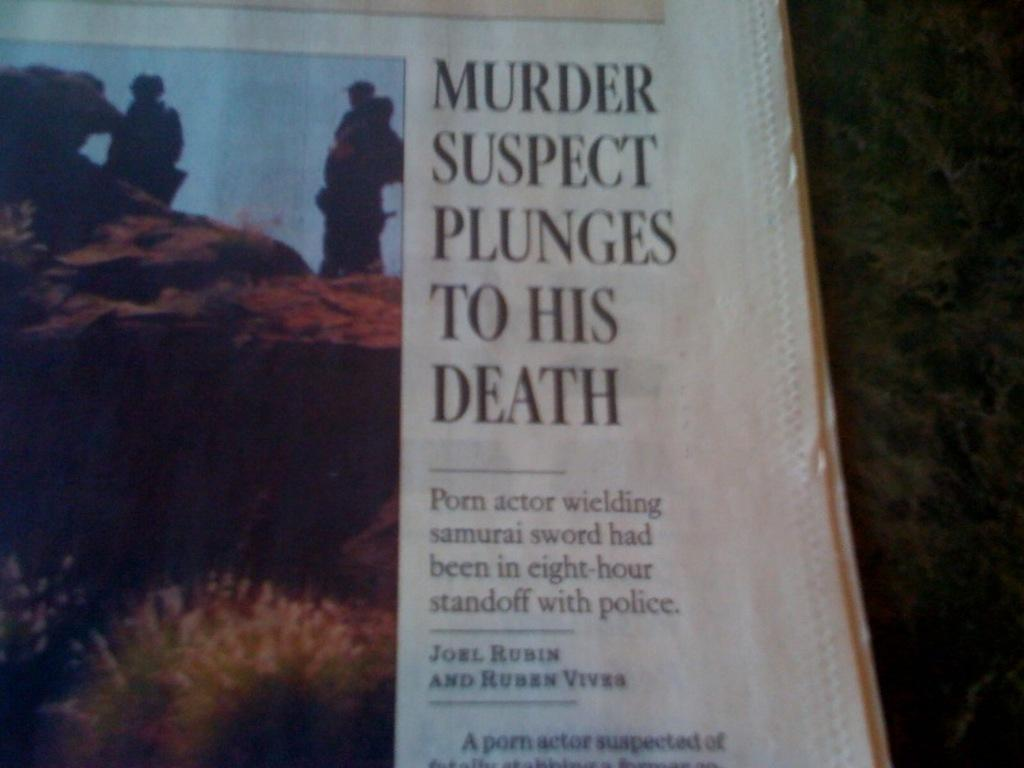Provide a one-sentence caption for the provided image. A newspaper shows an image next to a headline about a murder suspect. 